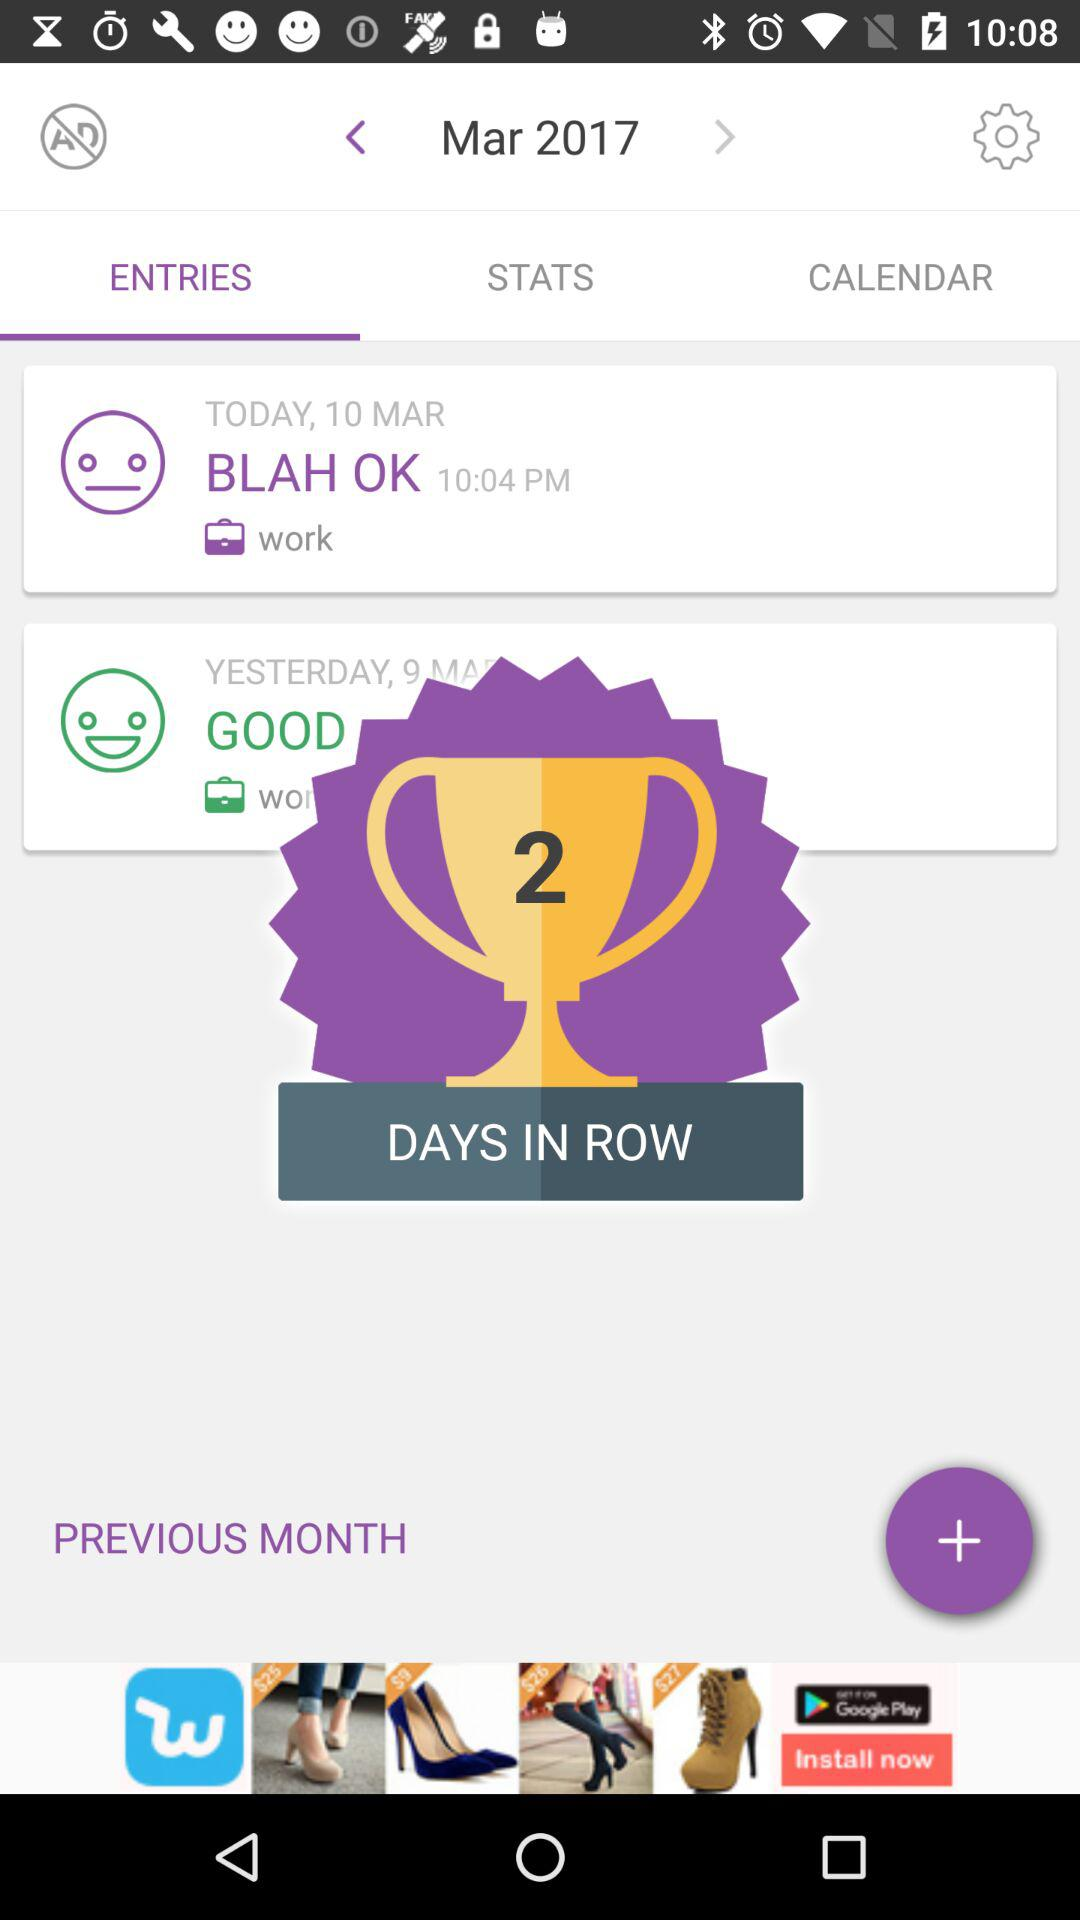What is the time of the "BLAH OK"? The time of the "BLAH OK" is 10:04 p.m. 